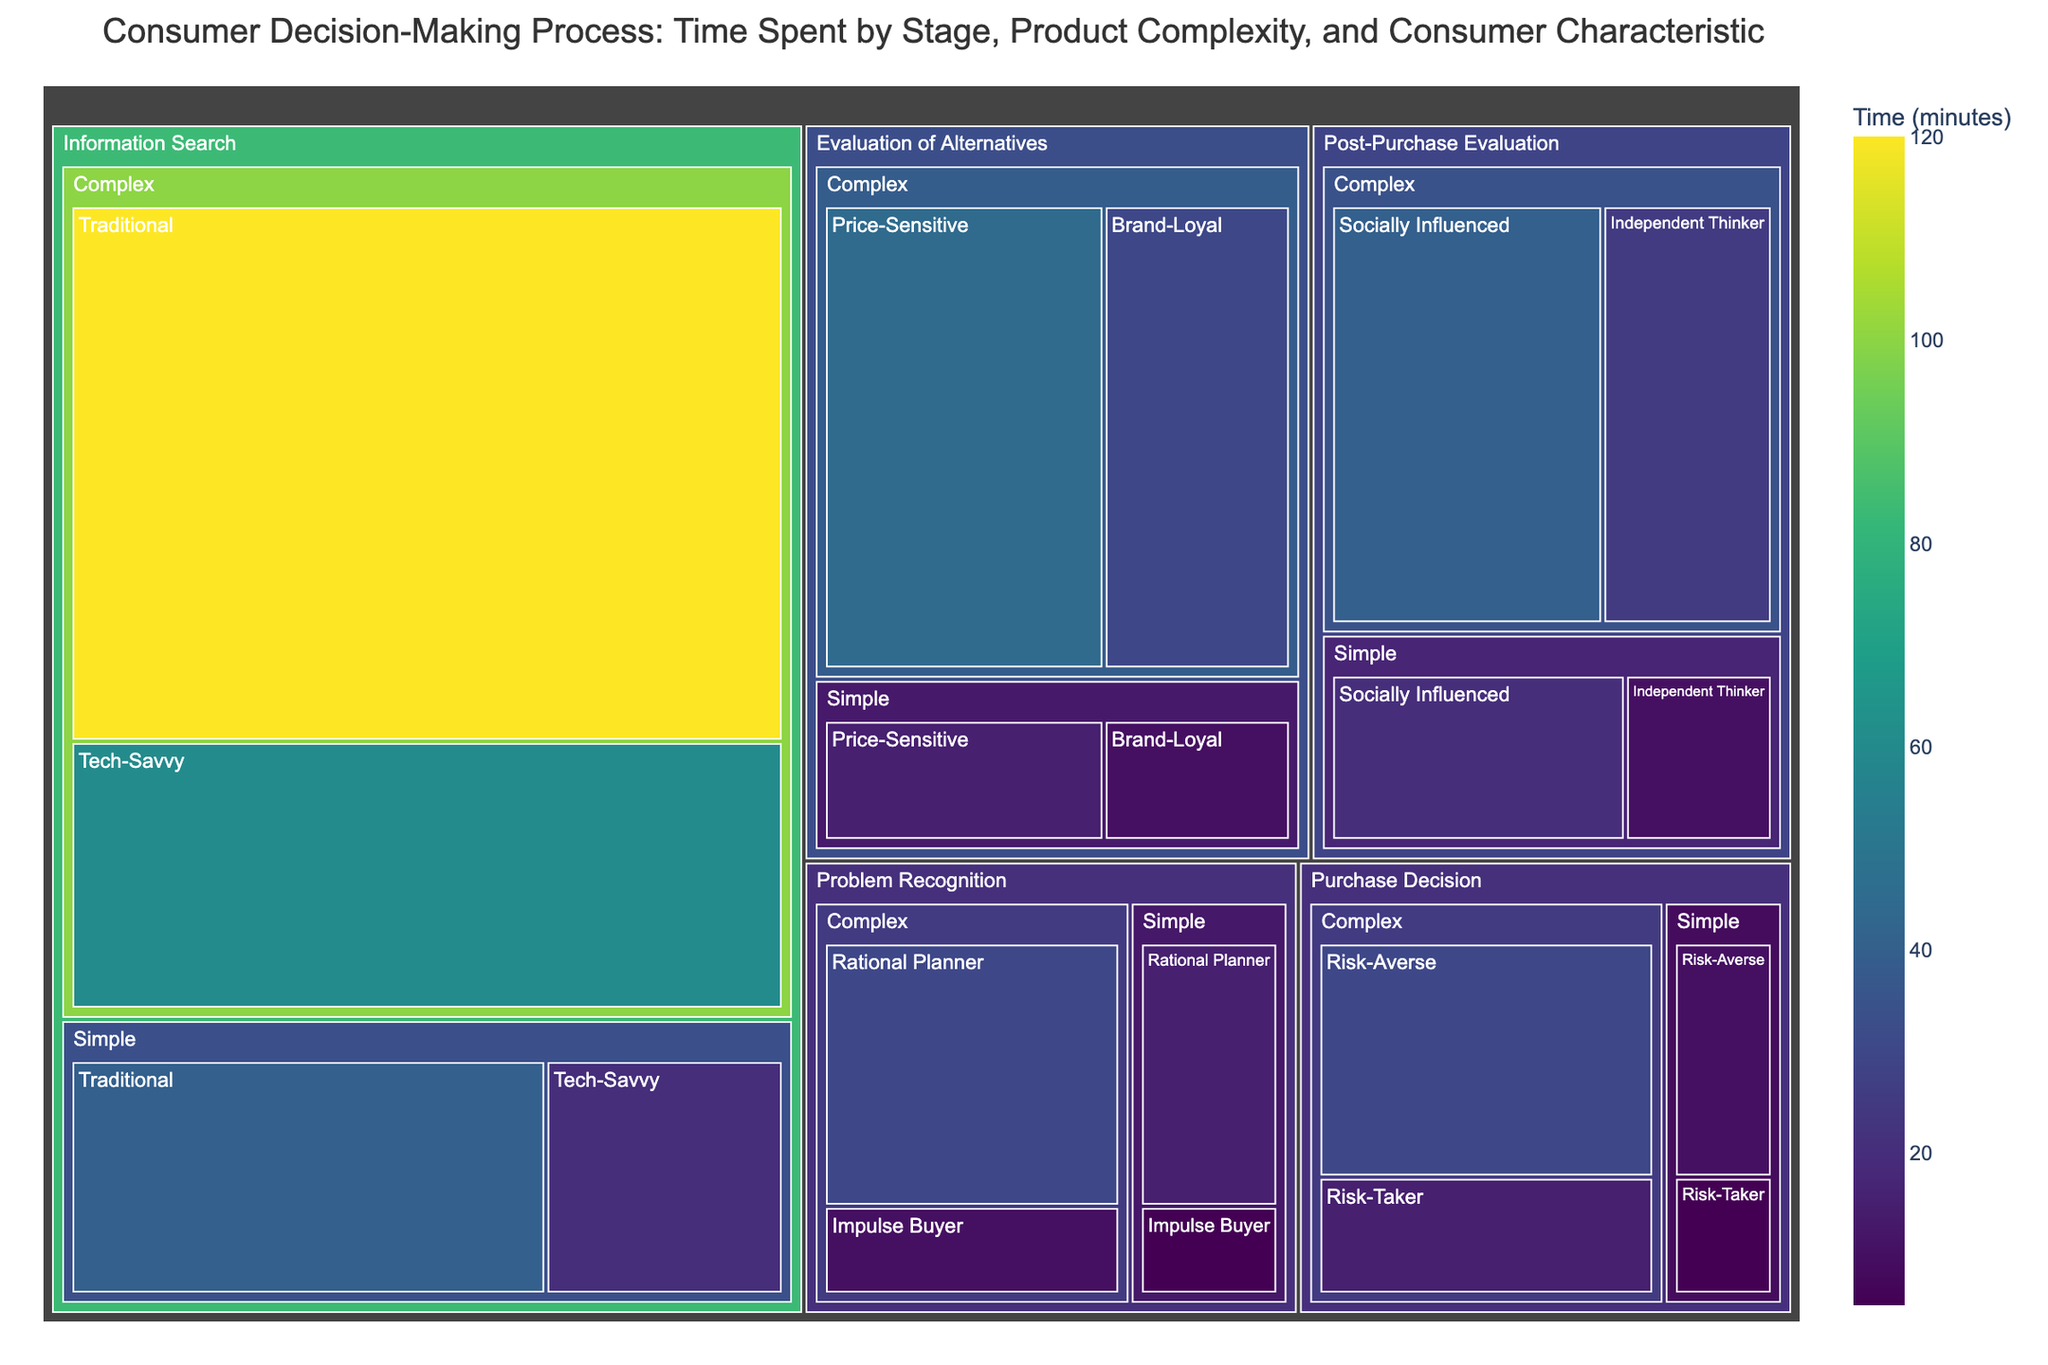What is the title of the treemap? The title of the treemap is displayed at the top of the figure, describing the content and focus of the chart.
Answer: Consumer Decision-Making Process: Time Spent by Stage, Product Complexity, and Consumer Characteristic Which stage has the longest time spent according to the treemap? By observing the size of the different sections in the treemap, the stage with the largest area represents the one with the longest time spent.
Answer: Information Search What is the total time spent by Impulse Buyers on both Simple and Complex products during the Problem Recognition stage? Look for the Impulse Buyer category under the Problem Recognition stage for both Simple and Complex products, then add the times together: 5 minutes (Simple) + 10 minutes (Complex).
Answer: 15 minutes Compare the time spent by Tech-Savvy consumers and Traditional consumers on Complex products during the Information Search stage. Which group spends more time? Locate the times for Tech-Savvy (60 minutes) and Traditional (120 minutes) consumers under Complex products in the Information Search stage and compare them.
Answer: Traditional consumers Which consumer characteristic group spends the least time on Simple products during the Purchase Decision stage? Identify the time spent by Risk-Averse (10 minutes) and Risk-Taker (5 minutes) consumers under Simple products in the Purchase Decision stage, and find the minimum value.
Answer: Risk-Taker How does the time spent by Brand-Loyal consumers on Complex products during the Evaluation of Alternatives stage compare to the time spent by Socially Influenced consumers on Complex products during the Post-Purchase Evaluation stage? Compare the time spent by Brand-Loyal consumers on Complex products during the Evaluation of Alternatives stage, which is 30 minutes, with the time spent by Socially Influenced consumers on Complex products during the Post-Purchase Evaluation stage, which is 40 minutes.
Answer: 10 minutes less Calculate the average time spent by Rational Planners on both Simple and Complex products during the Problem Recognition stage. Add the time spent by Rational Planners on both Simple and Complex products (15 minutes + 30 minutes) and divide by 2 (the number of data points): (15 + 30) / 2 = 22.5 minutes.
Answer: 22.5 minutes In which stage do Price-Sensitive consumers spend more time on Complex products compared to Simple products? Identify the time spent by Price-Sensitive consumers during the Evaluation of Alternatives stage for Complex (45 minutes) and Simple (15 minutes) products, and compare them.
Answer: Evaluation of Alternatives 